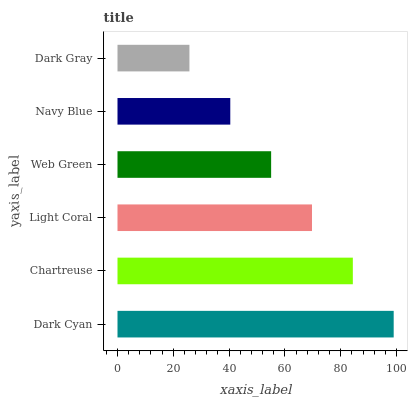Is Dark Gray the minimum?
Answer yes or no. Yes. Is Dark Cyan the maximum?
Answer yes or no. Yes. Is Chartreuse the minimum?
Answer yes or no. No. Is Chartreuse the maximum?
Answer yes or no. No. Is Dark Cyan greater than Chartreuse?
Answer yes or no. Yes. Is Chartreuse less than Dark Cyan?
Answer yes or no. Yes. Is Chartreuse greater than Dark Cyan?
Answer yes or no. No. Is Dark Cyan less than Chartreuse?
Answer yes or no. No. Is Light Coral the high median?
Answer yes or no. Yes. Is Web Green the low median?
Answer yes or no. Yes. Is Navy Blue the high median?
Answer yes or no. No. Is Chartreuse the low median?
Answer yes or no. No. 